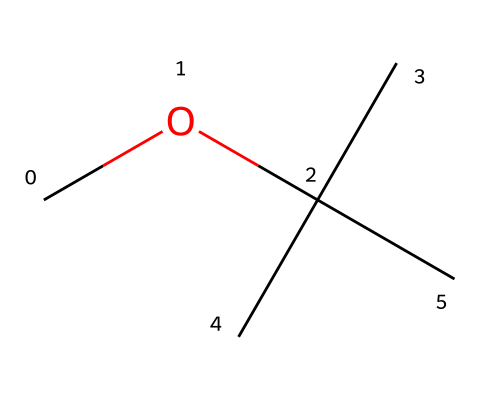What is the name of this chemical? The SMILES representation "COC(C)(C)C" corresponds to methyl tert-butyl ether. The "O" indicates the presence of an ether functional group, and the arrangement shows that it is based on a tert-butyl structure with a methoxy group (methyl attached to oxygen).
Answer: methyl tert-butyl ether How many carbon atoms are present in this molecule? By analyzing the SMILES "COC(C)(C)C", we see one carbon in the methoxy (-O-CH3) part and three additional carbons in the tert-butyl part. Therefore, in total, there are four carbon atoms.
Answer: four What type of functional group is present in this compound? In the structure represented by the SMILES "COC(C)(C)C", the presence of an oxygen atom between carbon atoms indicates that it features an ether functional group. Ethers are characterized by a carbon-oxygen-carbon bond configuration.
Answer: ether How many hydrogen atoms are associated with this molecule? Each carbon in the tert-butyl group is connected to enough hydrogen atoms to fulfill its tetravalency. The methyl group contributes three hydrogens, and the tert-butyl group contributes nine (three for each the three carbon atoms). Therefore, in total, there are 12 hydrogen atoms (H).
Answer: twelve Is this compound a primary, secondary, or tertiary ether? The structure of methyl tert-butyl ether indicates that it is a tertiary ether because it has a tertiary carbon atom connected to the oxygen atom; the oxygen is bonded to three carbon-containing groups, reflecting the tert-butyl's character with three carbon branching.
Answer: tertiary What is the significance of methyl tert-butyl ether in fuel preservation? Methyl tert-butyl ether is commonly used as an additive in gasoline, enhancing the octane rating and improving combustion efficiency and emissions, making it important for maintaining fuel quality over time.
Answer: fuel additive 